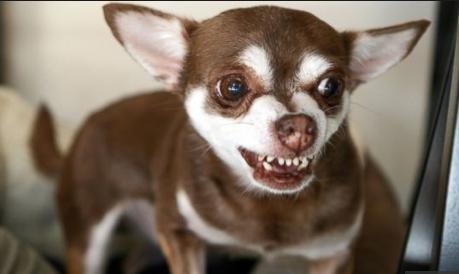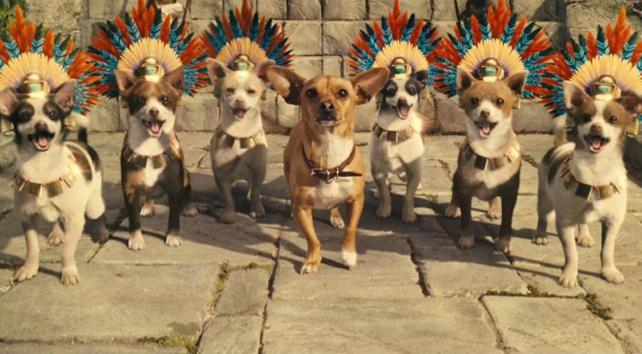The first image is the image on the left, the second image is the image on the right. For the images displayed, is the sentence "A chihuahua with its body turned toward the camera is baring its fangs." factually correct? Answer yes or no. Yes. The first image is the image on the left, the second image is the image on the right. Analyze the images presented: Is the assertion "The right image contains no more than one dog." valid? Answer yes or no. No. 